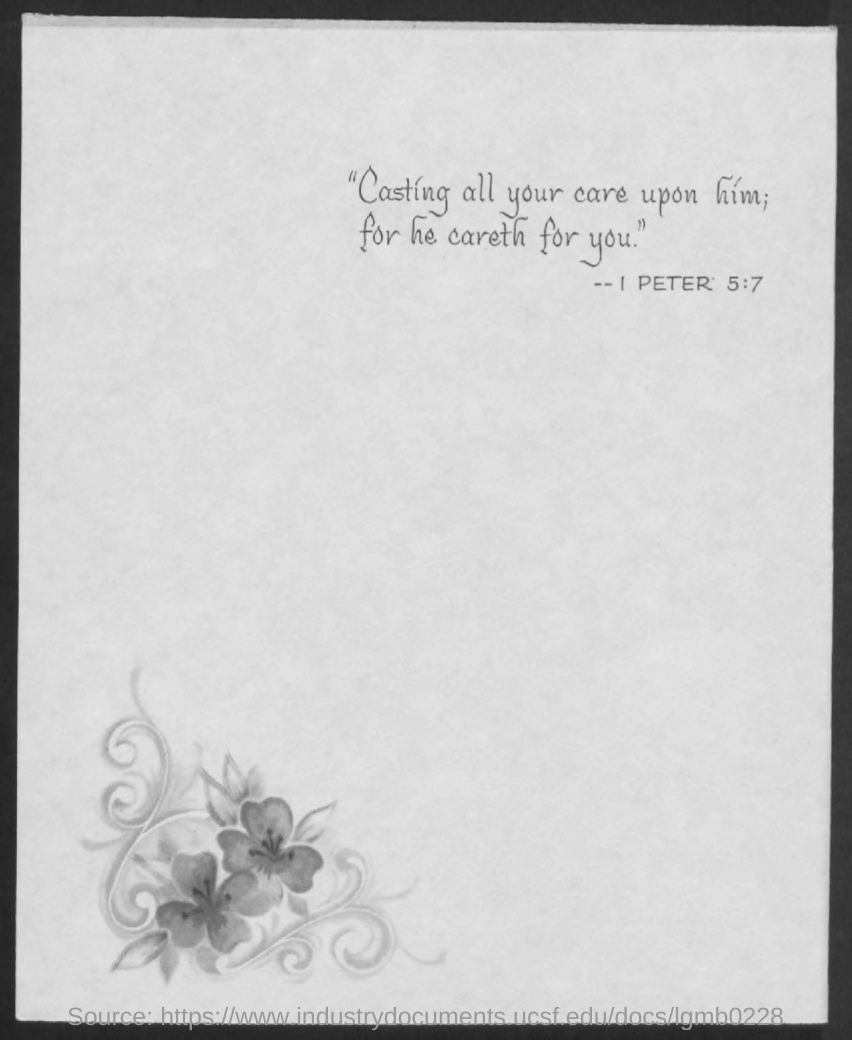Which Bible Verse is mentioned in the document?
Ensure brevity in your answer.  1 peter 5:7. 